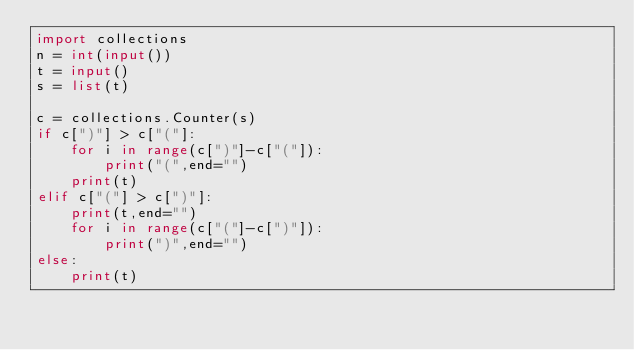Convert code to text. <code><loc_0><loc_0><loc_500><loc_500><_Python_>import collections
n = int(input())
t = input()
s = list(t)

c = collections.Counter(s)
if c[")"] > c["("]:
    for i in range(c[")"]-c["("]):
        print("(",end="")
    print(t)
elif c["("] > c[")"]:
    print(t,end="")
    for i in range(c["("]-c[")"]):
        print(")",end="")
else:
    print(t)</code> 